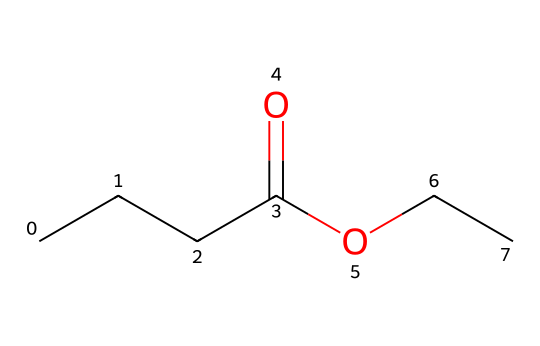What is the molecular formula of ethyl butyrate? By analyzing the SMILES representation, we can determine the number of each type of atom present. From the structure, we see: 4 carbons (C), 8 hydrogens (H), and 2 oxygens (O). Thus, the molecular formula is C4H8O2.
Answer: C4H8O2 How many carbon atoms are in ethyl butyrate? Looking at the SMILES representation, we can count the 'C' characters directly. There are 4 carbon atoms present in the structure.
Answer: 4 What functional group is present in ethyl butyrate? The structure indicates that there is a carboxylic acid group (—COOH) part of its ester component. Since this compound is an ester, it contains a carbonyl (C=O) bonded to an oxygen (—O) and the alkyl part.
Answer: ester What is the main aroma profile associated with ethyl butyrate? Ethyl butyrate is known for its fruity aroma, resembling that of pineapples or apples. This character is often attributed to its use in perfumes and flavorings.
Answer: fruity How many hydrogen atoms are bonded to the carbon atoms in ethyl butyrate? The structure provides insight into the number of hydrogen atoms. Each carbon typically forms 4 bonds. In ethyl butyrate, there are 8 hydrogen atoms connected to the 4 carbon atoms based on their bonding and structure.
Answer: 8 What characteristic makes ethyl butyrate a popular choice in flavoring and fragrance industries? Ethyl butyrate has a pleasant fruity aroma and thus is widely used in food products and perfumes. Its ability to evoke freshness and fruitiness contributes to its popularity.
Answer: pleasant aroma 